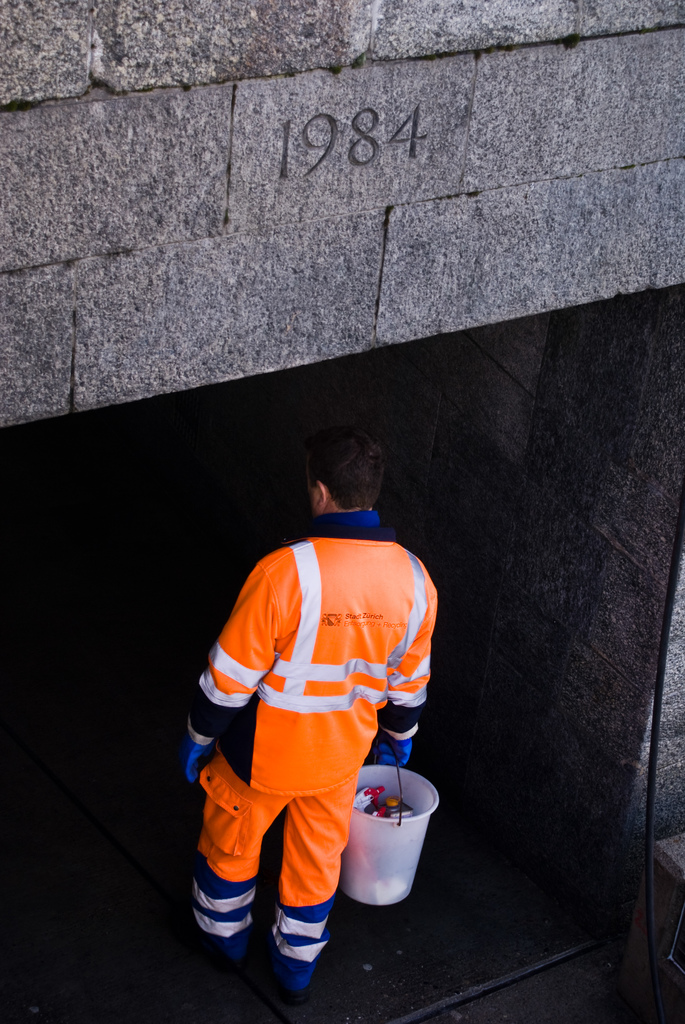Provide a one-sentence caption for the provided image. A worker dressed in a vibrant orange Stadt Zurich uniform carefully descends into a shadowy tunnel marked with the year 1984, carrying a bucket, possibly for maintenance or inspection purposes. 